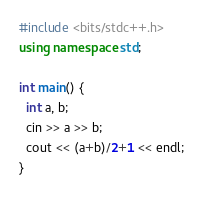Convert code to text. <code><loc_0><loc_0><loc_500><loc_500><_C++_>#include <bits/stdc++.h>
using namespace std;
 
int main() {
  int a, b;
  cin >> a >> b;
  cout << (a+b)/2+1 << endl;
}</code> 